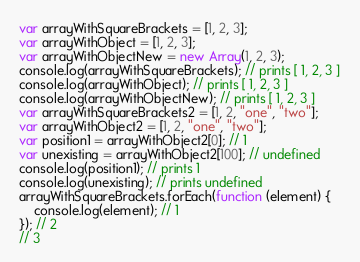<code> <loc_0><loc_0><loc_500><loc_500><_JavaScript_>var arrayWithSquareBrackets = [1, 2, 3];
var arrayWithObject = [1, 2, 3];
var arrayWithObjectNew = new Array(1, 2, 3);
console.log(arrayWithSquareBrackets); // prints [ 1, 2, 3 ]
console.log(arrayWithObject); // prints [ 1, 2, 3 ]
console.log(arrayWithObjectNew); // prints [ 1, 2, 3 ]
var arrayWithSquareBrackets2 = [1, 2, "one", "two"];
var arrayWithObject2 = [1, 2, "one", "two"];
var position1 = arrayWithObject2[0]; // 1
var unexisting = arrayWithObject2[100]; // undefined
console.log(position1); // prints 1
console.log(unexisting); // prints undefined
arrayWithSquareBrackets.forEach(function (element) {
    console.log(element); // 1
}); // 2
// 3 
</code> 